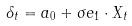<formula> <loc_0><loc_0><loc_500><loc_500>\delta _ { t } = a _ { 0 } + \sigma e _ { 1 } \cdot X _ { t }</formula> 